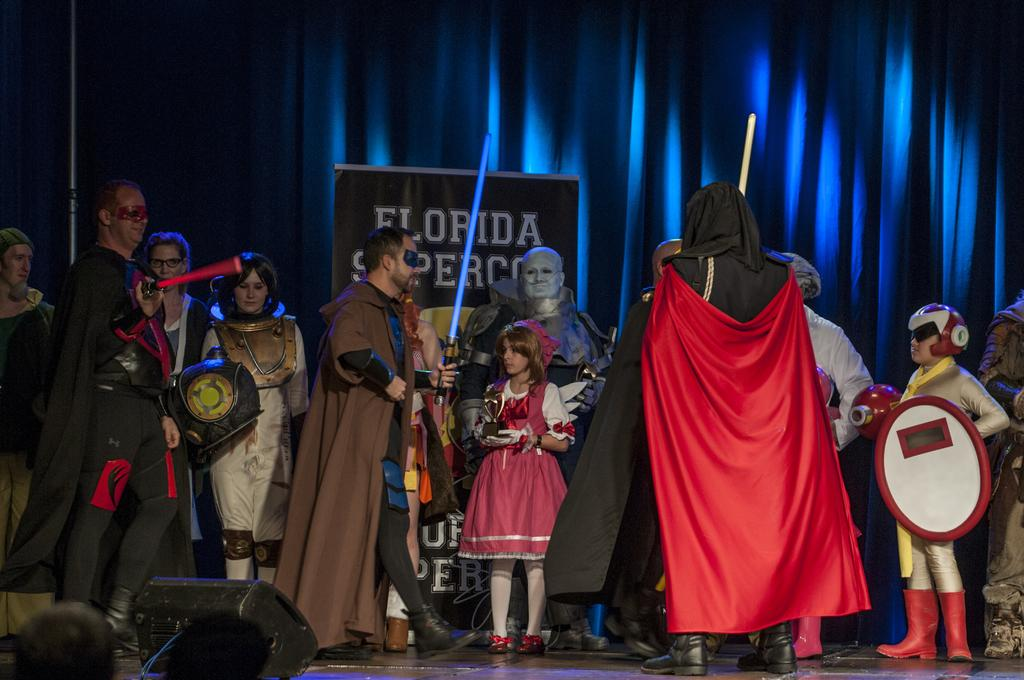What is happening in the image? There is a group of people in the image, and they are wearing costumes. Where are the people located in the image? The people are standing on a stage in the image. What can be seen in the image that might be related to a competition or performance? There is a trophy, swords, shields, and other objects in the image. What is visible in the background of the image? There is a banner and curtains in the background of the image. What type of sponge is being used by the people in the image? There is no sponge present in the image. What kind of experience can be gained by watching the people in the image? The image does not provide information about the experience of watching the people; it only shows them standing on a stage with costumes and props. 